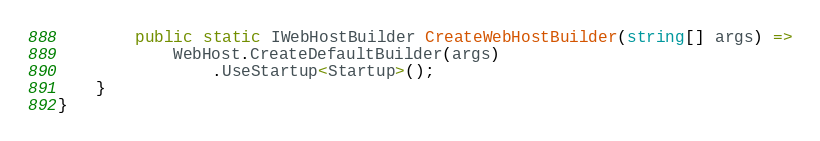<code> <loc_0><loc_0><loc_500><loc_500><_C#_>        public static IWebHostBuilder CreateWebHostBuilder(string[] args) =>
            WebHost.CreateDefaultBuilder(args)
                .UseStartup<Startup>();
    }
}
</code> 